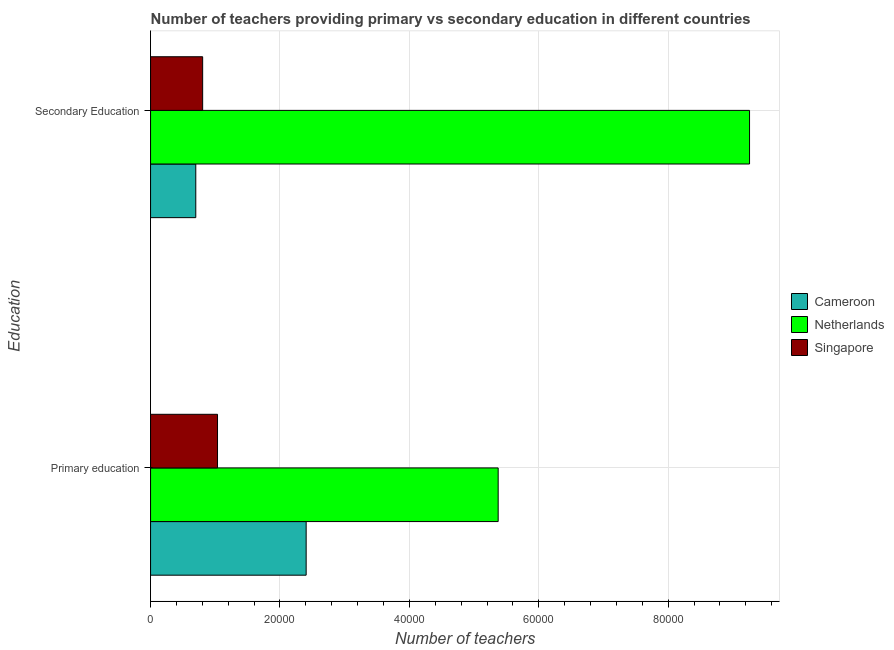How many groups of bars are there?
Offer a very short reply. 2. Are the number of bars per tick equal to the number of legend labels?
Give a very brief answer. Yes. How many bars are there on the 1st tick from the bottom?
Make the answer very short. 3. What is the label of the 1st group of bars from the top?
Offer a terse response. Secondary Education. What is the number of secondary teachers in Singapore?
Provide a short and direct response. 8050. Across all countries, what is the maximum number of secondary teachers?
Your response must be concise. 9.26e+04. Across all countries, what is the minimum number of secondary teachers?
Your answer should be very brief. 6988. In which country was the number of primary teachers maximum?
Make the answer very short. Netherlands. In which country was the number of primary teachers minimum?
Your answer should be compact. Singapore. What is the total number of primary teachers in the graph?
Your answer should be compact. 8.81e+04. What is the difference between the number of primary teachers in Cameroon and that in Singapore?
Keep it short and to the point. 1.37e+04. What is the difference between the number of secondary teachers in Netherlands and the number of primary teachers in Cameroon?
Offer a very short reply. 6.85e+04. What is the average number of secondary teachers per country?
Provide a succinct answer. 3.59e+04. What is the difference between the number of secondary teachers and number of primary teachers in Netherlands?
Provide a short and direct response. 3.88e+04. In how many countries, is the number of primary teachers greater than 20000 ?
Your answer should be compact. 2. What is the ratio of the number of primary teachers in Cameroon to that in Netherlands?
Offer a terse response. 0.45. Is the number of primary teachers in Singapore less than that in Cameroon?
Keep it short and to the point. Yes. In how many countries, is the number of primary teachers greater than the average number of primary teachers taken over all countries?
Make the answer very short. 1. What does the 2nd bar from the top in Primary education represents?
Provide a short and direct response. Netherlands. What does the 3rd bar from the bottom in Primary education represents?
Offer a terse response. Singapore. How many bars are there?
Your answer should be compact. 6. Are the values on the major ticks of X-axis written in scientific E-notation?
Your answer should be compact. No. Does the graph contain any zero values?
Your response must be concise. No. Does the graph contain grids?
Give a very brief answer. Yes. How many legend labels are there?
Provide a short and direct response. 3. How are the legend labels stacked?
Offer a terse response. Vertical. What is the title of the graph?
Give a very brief answer. Number of teachers providing primary vs secondary education in different countries. Does "Guatemala" appear as one of the legend labels in the graph?
Your response must be concise. No. What is the label or title of the X-axis?
Keep it short and to the point. Number of teachers. What is the label or title of the Y-axis?
Provide a succinct answer. Education. What is the Number of teachers in Cameroon in Primary education?
Your answer should be compact. 2.40e+04. What is the Number of teachers of Netherlands in Primary education?
Ensure brevity in your answer.  5.37e+04. What is the Number of teachers of Singapore in Primary education?
Provide a succinct answer. 1.03e+04. What is the Number of teachers of Cameroon in Secondary Education?
Your answer should be very brief. 6988. What is the Number of teachers of Netherlands in Secondary Education?
Provide a succinct answer. 9.26e+04. What is the Number of teachers in Singapore in Secondary Education?
Provide a short and direct response. 8050. Across all Education, what is the maximum Number of teachers in Cameroon?
Provide a succinct answer. 2.40e+04. Across all Education, what is the maximum Number of teachers in Netherlands?
Ensure brevity in your answer.  9.26e+04. Across all Education, what is the maximum Number of teachers of Singapore?
Your answer should be compact. 1.03e+04. Across all Education, what is the minimum Number of teachers in Cameroon?
Keep it short and to the point. 6988. Across all Education, what is the minimum Number of teachers of Netherlands?
Give a very brief answer. 5.37e+04. Across all Education, what is the minimum Number of teachers of Singapore?
Provide a succinct answer. 8050. What is the total Number of teachers of Cameroon in the graph?
Your response must be concise. 3.10e+04. What is the total Number of teachers of Netherlands in the graph?
Offer a terse response. 1.46e+05. What is the total Number of teachers in Singapore in the graph?
Your answer should be very brief. 1.84e+04. What is the difference between the Number of teachers in Cameroon in Primary education and that in Secondary Education?
Provide a succinct answer. 1.71e+04. What is the difference between the Number of teachers in Netherlands in Primary education and that in Secondary Education?
Keep it short and to the point. -3.88e+04. What is the difference between the Number of teachers of Singapore in Primary education and that in Secondary Education?
Ensure brevity in your answer.  2297. What is the difference between the Number of teachers in Cameroon in Primary education and the Number of teachers in Netherlands in Secondary Education?
Give a very brief answer. -6.85e+04. What is the difference between the Number of teachers in Cameroon in Primary education and the Number of teachers in Singapore in Secondary Education?
Keep it short and to the point. 1.60e+04. What is the difference between the Number of teachers in Netherlands in Primary education and the Number of teachers in Singapore in Secondary Education?
Offer a terse response. 4.57e+04. What is the average Number of teachers of Cameroon per Education?
Offer a terse response. 1.55e+04. What is the average Number of teachers of Netherlands per Education?
Offer a very short reply. 7.31e+04. What is the average Number of teachers in Singapore per Education?
Make the answer very short. 9198.5. What is the difference between the Number of teachers of Cameroon and Number of teachers of Netherlands in Primary education?
Offer a very short reply. -2.97e+04. What is the difference between the Number of teachers of Cameroon and Number of teachers of Singapore in Primary education?
Your answer should be compact. 1.37e+04. What is the difference between the Number of teachers in Netherlands and Number of teachers in Singapore in Primary education?
Make the answer very short. 4.34e+04. What is the difference between the Number of teachers in Cameroon and Number of teachers in Netherlands in Secondary Education?
Give a very brief answer. -8.56e+04. What is the difference between the Number of teachers of Cameroon and Number of teachers of Singapore in Secondary Education?
Your answer should be compact. -1062. What is the difference between the Number of teachers in Netherlands and Number of teachers in Singapore in Secondary Education?
Provide a succinct answer. 8.45e+04. What is the ratio of the Number of teachers of Cameroon in Primary education to that in Secondary Education?
Offer a very short reply. 3.44. What is the ratio of the Number of teachers in Netherlands in Primary education to that in Secondary Education?
Ensure brevity in your answer.  0.58. What is the ratio of the Number of teachers of Singapore in Primary education to that in Secondary Education?
Keep it short and to the point. 1.29. What is the difference between the highest and the second highest Number of teachers of Cameroon?
Keep it short and to the point. 1.71e+04. What is the difference between the highest and the second highest Number of teachers of Netherlands?
Offer a very short reply. 3.88e+04. What is the difference between the highest and the second highest Number of teachers of Singapore?
Your answer should be compact. 2297. What is the difference between the highest and the lowest Number of teachers in Cameroon?
Offer a terse response. 1.71e+04. What is the difference between the highest and the lowest Number of teachers in Netherlands?
Offer a very short reply. 3.88e+04. What is the difference between the highest and the lowest Number of teachers in Singapore?
Provide a succinct answer. 2297. 